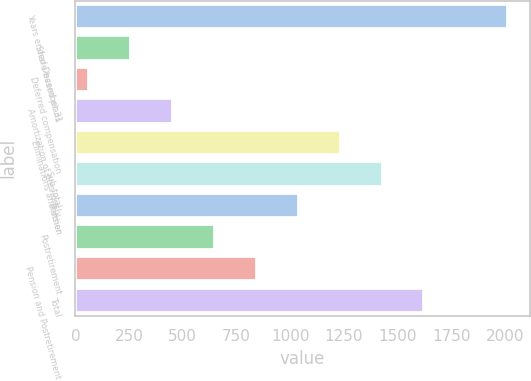<chart> <loc_0><loc_0><loc_500><loc_500><bar_chart><fcel>Years ended December 31<fcel>Share-based plans<fcel>Deferred compensation<fcel>Amortization of previously<fcel>Eliminations and other<fcel>Sub-total<fcel>Pension<fcel>Postretirement<fcel>Pension and Postretirement<fcel>Total<nl><fcel>2015<fcel>258.2<fcel>63<fcel>453.4<fcel>1234.2<fcel>1429.4<fcel>1039<fcel>648.6<fcel>843.8<fcel>1624.6<nl></chart> 